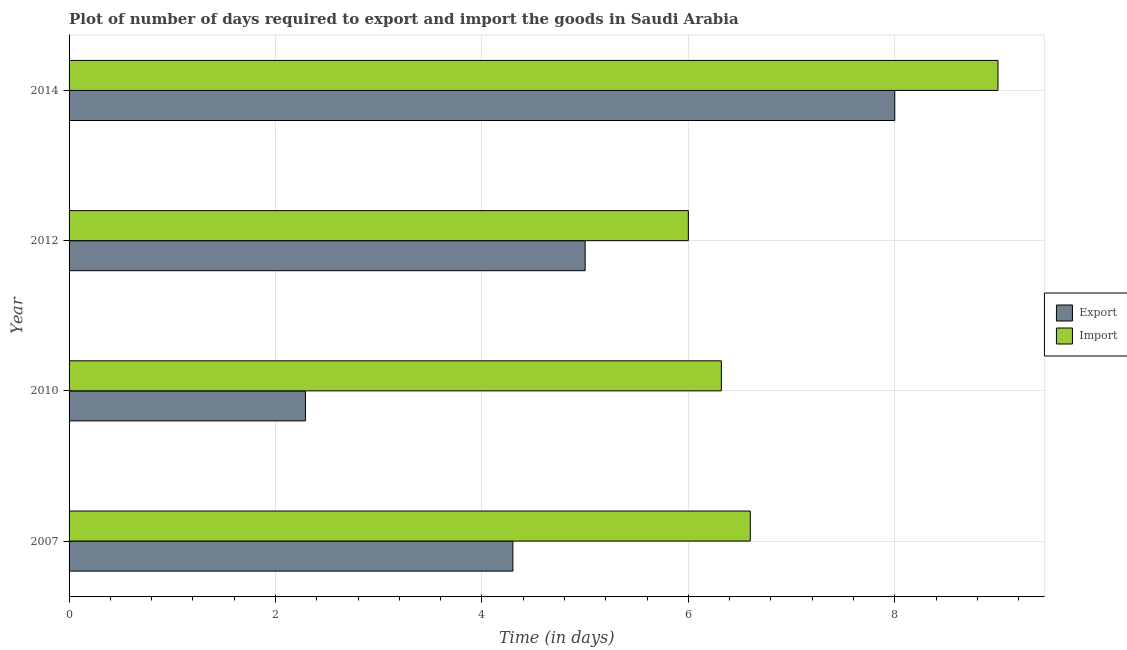How many different coloured bars are there?
Your answer should be compact. 2. How many groups of bars are there?
Your response must be concise. 4. Are the number of bars on each tick of the Y-axis equal?
Your answer should be compact. Yes. How many bars are there on the 2nd tick from the top?
Your answer should be very brief. 2. What is the label of the 2nd group of bars from the top?
Your response must be concise. 2012. In how many cases, is the number of bars for a given year not equal to the number of legend labels?
Your response must be concise. 0. Across all years, what is the minimum time required to export?
Your answer should be very brief. 2.29. In which year was the time required to import maximum?
Offer a terse response. 2014. What is the total time required to export in the graph?
Provide a short and direct response. 19.59. What is the difference between the time required to import in 2012 and that in 2014?
Provide a succinct answer. -3. What is the difference between the time required to import in 2007 and the time required to export in 2014?
Provide a succinct answer. -1.4. What is the average time required to import per year?
Make the answer very short. 6.98. In the year 2007, what is the difference between the time required to export and time required to import?
Give a very brief answer. -2.3. What is the ratio of the time required to export in 2007 to that in 2012?
Provide a short and direct response. 0.86. What does the 1st bar from the top in 2012 represents?
Your response must be concise. Import. What does the 2nd bar from the bottom in 2010 represents?
Ensure brevity in your answer.  Import. How many bars are there?
Provide a succinct answer. 8. Are all the bars in the graph horizontal?
Provide a succinct answer. Yes. How many years are there in the graph?
Ensure brevity in your answer.  4. What is the difference between two consecutive major ticks on the X-axis?
Offer a very short reply. 2. Does the graph contain any zero values?
Offer a very short reply. No. Where does the legend appear in the graph?
Make the answer very short. Center right. How many legend labels are there?
Your answer should be compact. 2. How are the legend labels stacked?
Your answer should be very brief. Vertical. What is the title of the graph?
Keep it short and to the point. Plot of number of days required to export and import the goods in Saudi Arabia. Does "Personal remittances" appear as one of the legend labels in the graph?
Ensure brevity in your answer.  No. What is the label or title of the X-axis?
Provide a succinct answer. Time (in days). What is the label or title of the Y-axis?
Keep it short and to the point. Year. What is the Time (in days) of Export in 2007?
Give a very brief answer. 4.3. What is the Time (in days) in Export in 2010?
Ensure brevity in your answer.  2.29. What is the Time (in days) of Import in 2010?
Offer a terse response. 6.32. What is the Time (in days) in Export in 2014?
Your response must be concise. 8. Across all years, what is the maximum Time (in days) in Import?
Your answer should be very brief. 9. Across all years, what is the minimum Time (in days) of Export?
Make the answer very short. 2.29. What is the total Time (in days) in Export in the graph?
Keep it short and to the point. 19.59. What is the total Time (in days) in Import in the graph?
Keep it short and to the point. 27.92. What is the difference between the Time (in days) in Export in 2007 and that in 2010?
Keep it short and to the point. 2.01. What is the difference between the Time (in days) in Import in 2007 and that in 2010?
Offer a very short reply. 0.28. What is the difference between the Time (in days) of Export in 2007 and that in 2012?
Keep it short and to the point. -0.7. What is the difference between the Time (in days) in Export in 2010 and that in 2012?
Offer a very short reply. -2.71. What is the difference between the Time (in days) in Import in 2010 and that in 2012?
Your answer should be compact. 0.32. What is the difference between the Time (in days) of Export in 2010 and that in 2014?
Provide a short and direct response. -5.71. What is the difference between the Time (in days) of Import in 2010 and that in 2014?
Your response must be concise. -2.68. What is the difference between the Time (in days) of Export in 2012 and that in 2014?
Keep it short and to the point. -3. What is the difference between the Time (in days) of Export in 2007 and the Time (in days) of Import in 2010?
Your response must be concise. -2.02. What is the difference between the Time (in days) of Export in 2007 and the Time (in days) of Import in 2012?
Give a very brief answer. -1.7. What is the difference between the Time (in days) of Export in 2010 and the Time (in days) of Import in 2012?
Your answer should be very brief. -3.71. What is the difference between the Time (in days) of Export in 2010 and the Time (in days) of Import in 2014?
Ensure brevity in your answer.  -6.71. What is the difference between the Time (in days) in Export in 2012 and the Time (in days) in Import in 2014?
Make the answer very short. -4. What is the average Time (in days) in Export per year?
Ensure brevity in your answer.  4.9. What is the average Time (in days) in Import per year?
Your answer should be very brief. 6.98. In the year 2007, what is the difference between the Time (in days) of Export and Time (in days) of Import?
Offer a very short reply. -2.3. In the year 2010, what is the difference between the Time (in days) in Export and Time (in days) in Import?
Offer a terse response. -4.03. In the year 2012, what is the difference between the Time (in days) of Export and Time (in days) of Import?
Keep it short and to the point. -1. What is the ratio of the Time (in days) in Export in 2007 to that in 2010?
Provide a short and direct response. 1.88. What is the ratio of the Time (in days) in Import in 2007 to that in 2010?
Keep it short and to the point. 1.04. What is the ratio of the Time (in days) in Export in 2007 to that in 2012?
Ensure brevity in your answer.  0.86. What is the ratio of the Time (in days) of Import in 2007 to that in 2012?
Offer a terse response. 1.1. What is the ratio of the Time (in days) of Export in 2007 to that in 2014?
Your answer should be compact. 0.54. What is the ratio of the Time (in days) of Import in 2007 to that in 2014?
Your response must be concise. 0.73. What is the ratio of the Time (in days) of Export in 2010 to that in 2012?
Your response must be concise. 0.46. What is the ratio of the Time (in days) of Import in 2010 to that in 2012?
Your answer should be very brief. 1.05. What is the ratio of the Time (in days) in Export in 2010 to that in 2014?
Your response must be concise. 0.29. What is the ratio of the Time (in days) of Import in 2010 to that in 2014?
Ensure brevity in your answer.  0.7. What is the ratio of the Time (in days) in Import in 2012 to that in 2014?
Give a very brief answer. 0.67. What is the difference between the highest and the second highest Time (in days) in Export?
Keep it short and to the point. 3. What is the difference between the highest and the second highest Time (in days) of Import?
Ensure brevity in your answer.  2.4. What is the difference between the highest and the lowest Time (in days) in Export?
Your answer should be compact. 5.71. What is the difference between the highest and the lowest Time (in days) of Import?
Your answer should be compact. 3. 